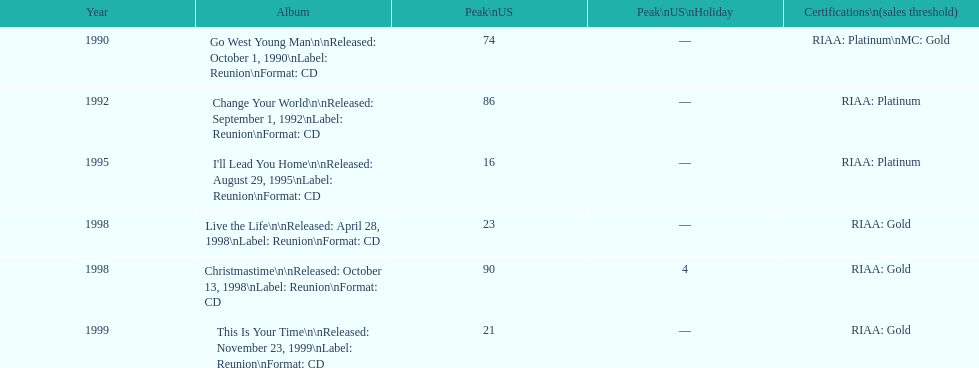On the us chart, which michael w. smith album achieved the highest position? I'll Lead You Home. 